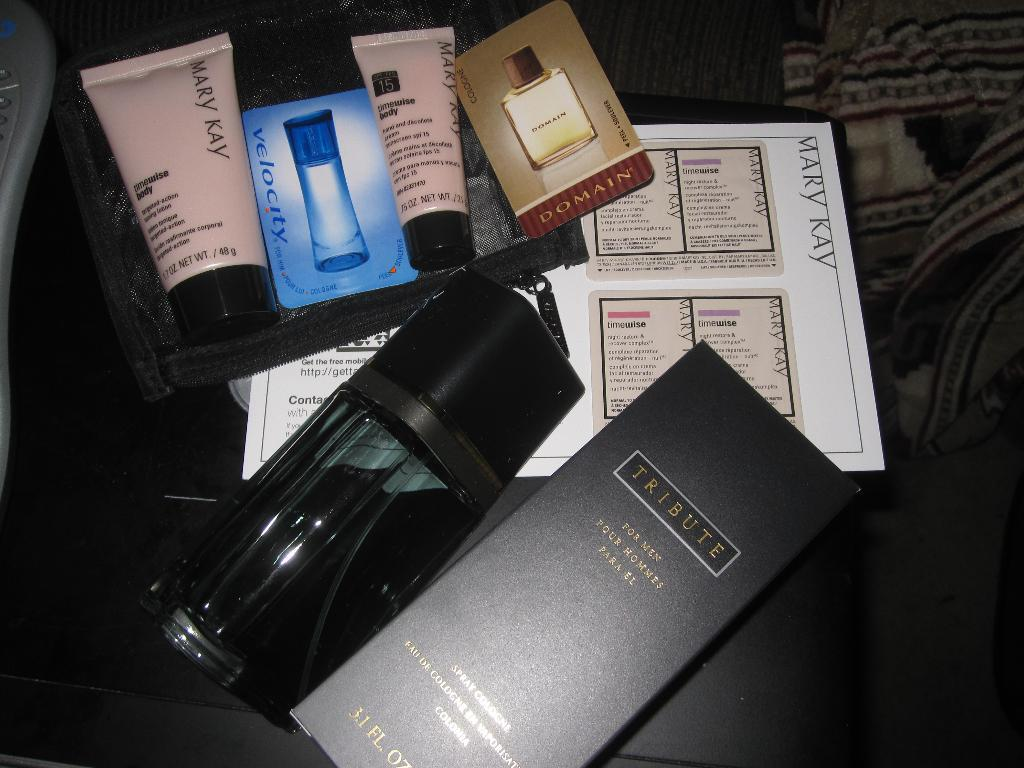<image>
Provide a brief description of the given image. Box of perfume including a black box that says Tribute. 